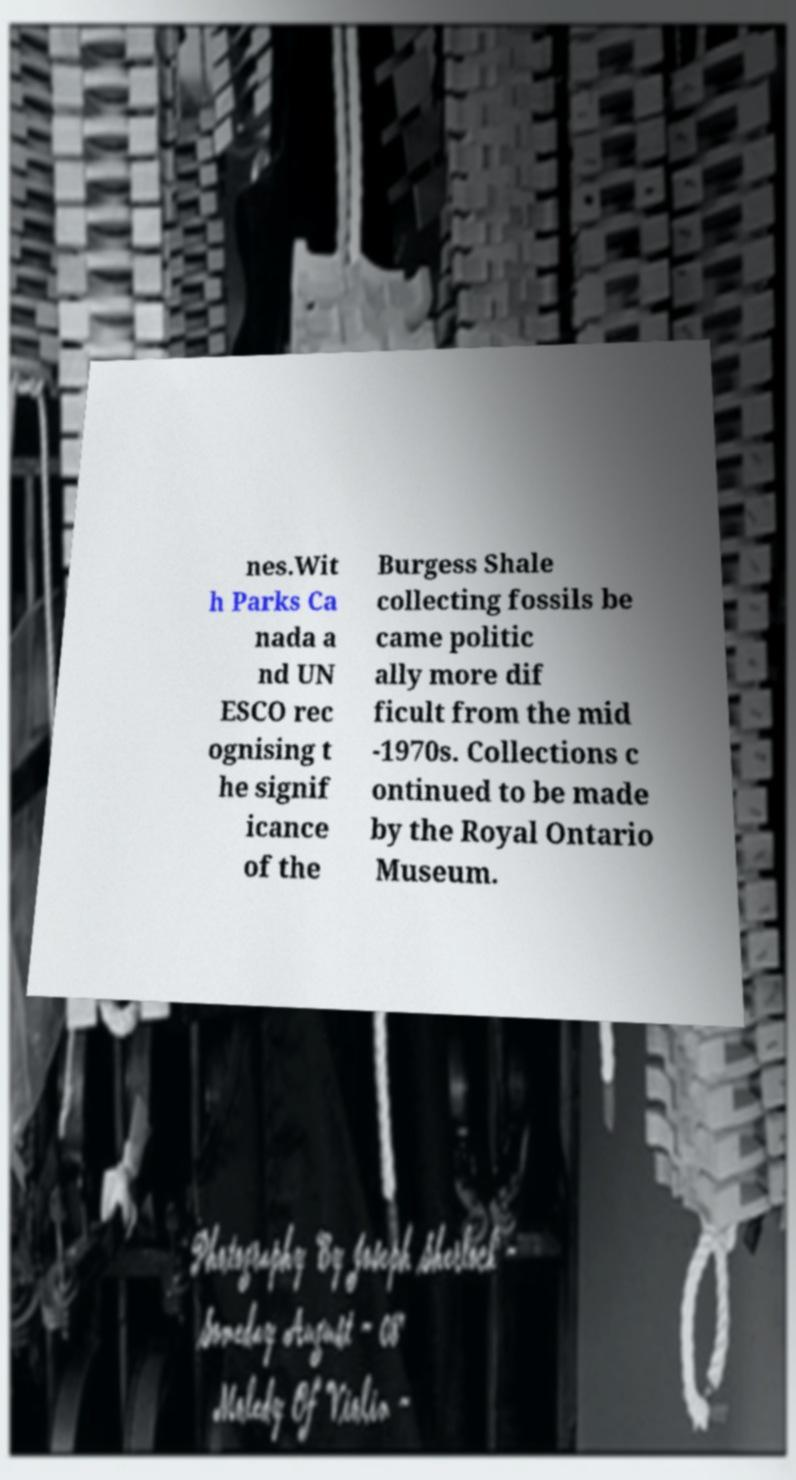For documentation purposes, I need the text within this image transcribed. Could you provide that? nes.Wit h Parks Ca nada a nd UN ESCO rec ognising t he signif icance of the Burgess Shale collecting fossils be came politic ally more dif ficult from the mid -1970s. Collections c ontinued to be made by the Royal Ontario Museum. 